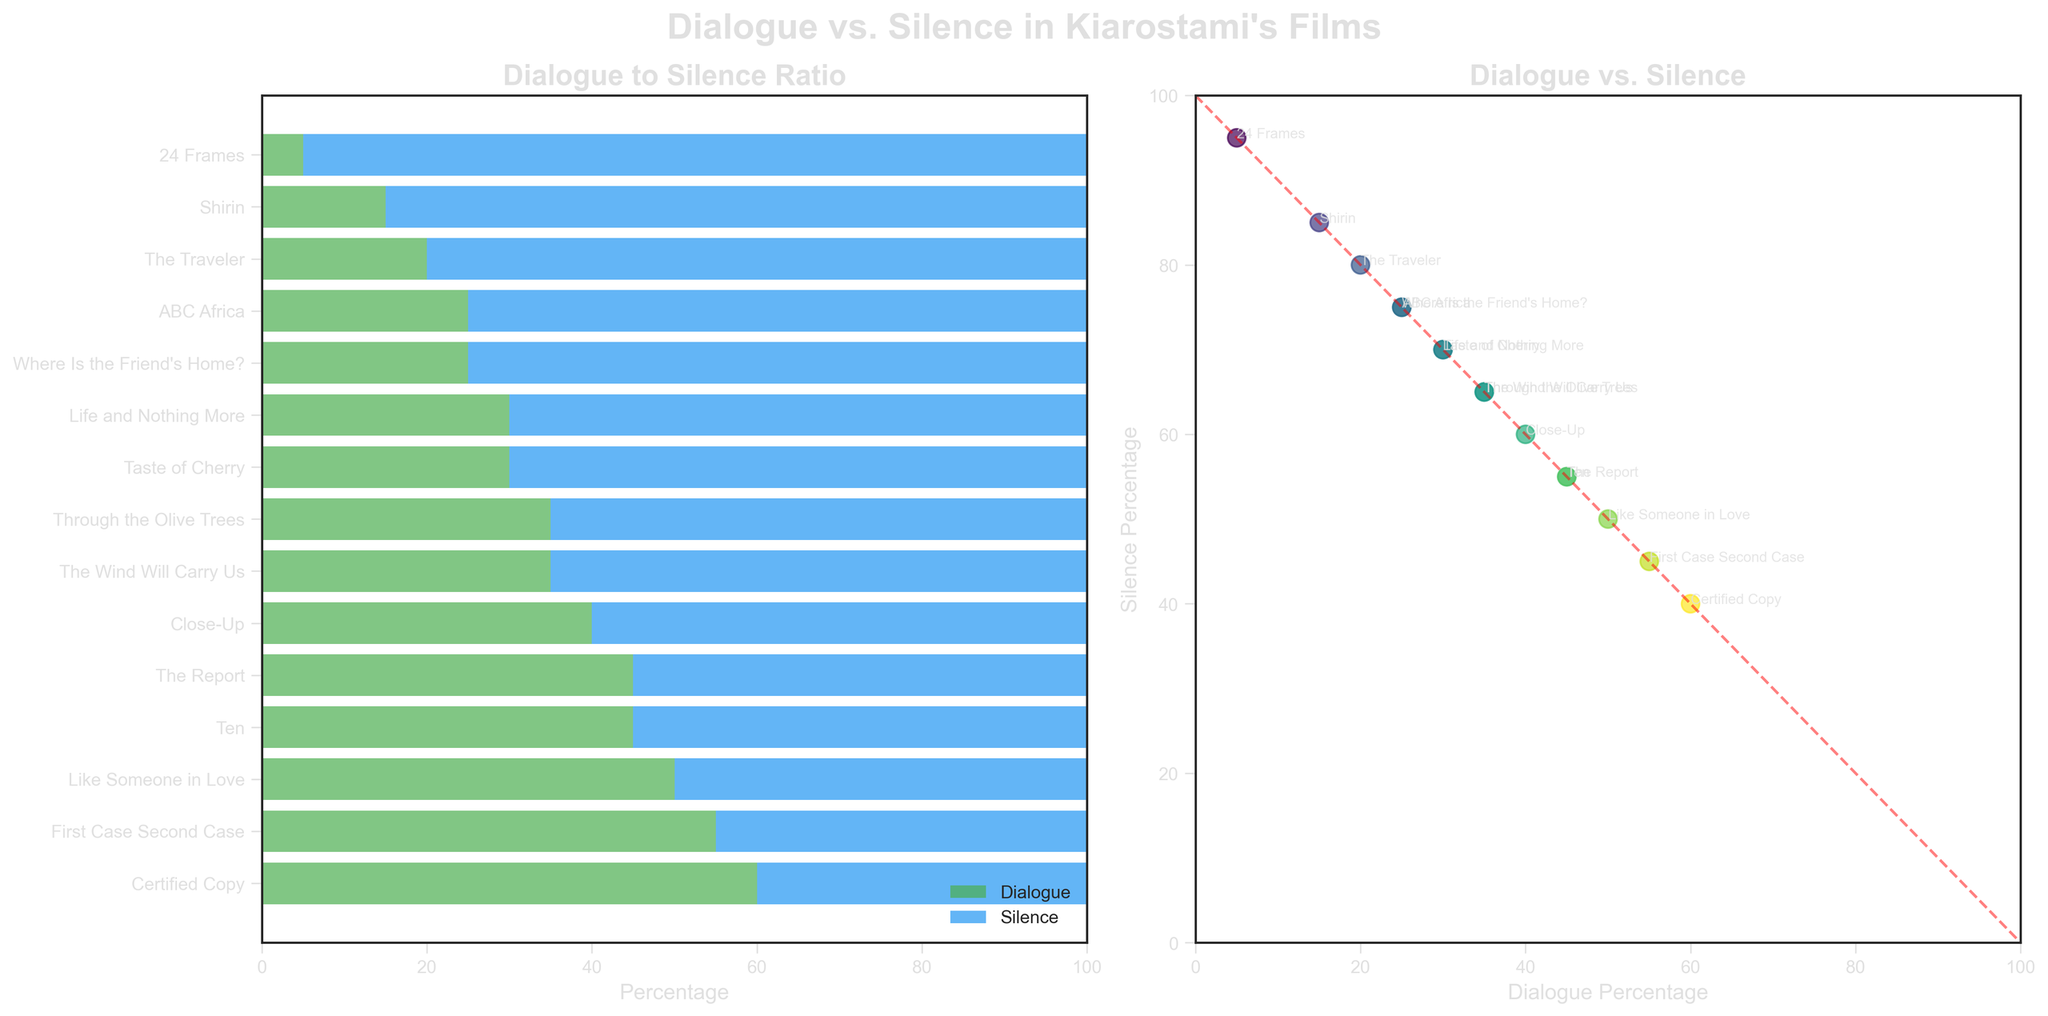Which film has the highest dialogue percentage? In the horizontal bar chart, look for the longest green bar labeled 'Dialogue'. The film "Certified Copy" has the highest dialogue percentage.
Answer: Certified Copy Which two films have the lowest and the second lowest dialogue percentages? In the horizontal bar chart, look for the shortest green bars labeled 'Dialogue'. "24 Frames" has the lowest dialogue percentage, followed by "Shirin".
Answer: 24 Frames and Shirin How much more percentage of dialogue does "Like Someone in Love" have compared to "The Traveler"? From the bars, "Like Someone in Love" has 50% dialogue and "The Traveler" has 20% dialogue. The difference is 50% - 20% = 30%.
Answer: 30% Is there a film where the dialogue and silence percentages are exactly equal? In the horizontal bar chart, find a film where the green and blue bars have an equal length. "Like Someone in Love" has equal dialogue and silence at 50%.
Answer: Like Someone in Love What is the average dialogue percentage across all films? Add up all the dialogue percentages: 30 + 35 + 45 + 60 + 50 + 40 + 35 + 25 + 30 + 20 + 45 + 55 + 25 + 15 + 5 = 515. There are 15 films, so the average is 515 / 15 ≈ 34.33%.
Answer: 34.33% Which films have a dialogue percentage between 30% and 40%? Check the green bars labeled 'Dialogue' in the horizontal bar chart between 30% and 40%. "Taste of Cherry", "The Wind Will Carry Us", "Close-Up", "Through the Olive Trees", and "Life and Nothing More" fall within this range.
Answer: Taste of Cherry, The Wind Will Carry Us, Close-Up, Through the Olive Trees, Life and Nothing More Compare the dialogue percentages of “ABC Africa” and “Where Is the Friend's Home?”. Which film has a higher percentage and by how much? In the bar chart, "ABC Africa" has a dialogue percentage of 25% and "Where Is the Friend's Home?" has 25%. They both have the same dialogue percentage.
Answer: They have the same percentage What is the relationship between dialogue and silence percentages in Kiarostami's films? In the scatter plot, observe that as the dialogue percentage increases, the silence percentage decreases. This is shown by the descending trend along the diagonal red line.
Answer: Inversely related Which films are closest in dialogue percentage? In the scatter plot, look for points that are closest horizontally. "Where Is the Friend's Home?" and "ABC Africa" both have a dialogue percentage of 25%.
Answer: Where Is the Friend's Home? and ABC Africa For the film with the highest silence percentage, what is its dialogue percentage? In the bar chart, the film with the highest silence percentage is "24 Frames" with a silence percentage of 95%, which means its dialogue percentage is 5%.
Answer: 5% 